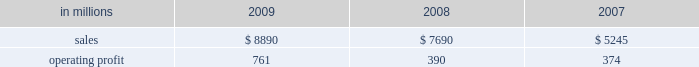Distribution xpedx , our north american merchant distribution business , distributes products and services to a number of customer markets including : commercial printers with printing papers and graphic pre-press , printing presses and post-press equipment ; building services and away-from-home markets with facility supplies ; manufacturers with packaging supplies and equipment ; and to a growing number of customers , we exclusively provide distribution capabilities including warehousing and delivery services .
Xpedx is the leading wholesale distribution marketer in these customer and product segments in north america , operating 122 warehouse locations and 130 retail stores in the united states , mexico and cana- forest products international paper owns and manages approx- imately 200000 acres of forestlands and develop- ment properties in the united states , mostly in the south .
Our remaining forestlands are managed as a portfolio to optimize the economic value to our shareholders .
Most of our portfolio represents prop- erties that are likely to be sold to investors and other buyers for various purposes .
Specialty businesses and other chemicals : this business was sold in the first quarter of 2007 .
Ilim holding s.a .
In october 2007 , international paper and ilim holding s.a .
( ilim ) completed a 50:50 joint venture to operate a pulp and paper business located in russia .
Ilim 2019s facilities include three paper mills located in bratsk , ust-ilimsk , and koryazhma , russia , with combined total pulp and paper capacity of over 2.5 million tons .
Ilim has exclusive harvesting rights on timberland and forest areas exceeding 12.8 million acres ( 5.2 million hectares ) .
Products and brand designations appearing in italics are trademarks of international paper or a related company .
Industry segment results industrial packaging demand for industrial packaging products is closely correlated with non-durable industrial goods pro- duction , as well as with demand for processed foods , poultry , meat and agricultural products .
In addition to prices and volumes , major factors affecting the profitability of industrial packaging are raw material and energy costs , freight costs , manufacturing effi- ciency and product mix .
Industrial packaging results for 2009 and 2008 include the cbpr business acquired in the 2008 third quarter .
Net sales for 2009 increased 16% ( 16 % ) to $ 8.9 billion compared with $ 7.7 billion in 2008 , and 69% ( 69 % ) compared with $ 5.2 billion in 2007 .
Operating profits were 95% ( 95 % ) higher in 2009 than in 2008 and more than double 2007 levels .
Benefits from higher total year-over-year shipments , including the impact of the cbpr business , ( $ 11 million ) , favorable operating costs ( $ 294 million ) , and lower raw material and freight costs ( $ 295 million ) were parti- ally offset by the effects of lower price realizations ( $ 243 million ) , higher corporate overhead allocations ( $ 85 million ) , incremental integration costs asso- ciated with the acquisition of the cbpr business ( $ 3 million ) and higher other costs ( $ 7 million ) .
Additionally , operating profits in 2009 included a gain of $ 849 million relating to alternative fuel mix- ture credits , u.s .
Plant closure costs of $ 653 million , and costs associated with the shutdown of the eti- enne mill in france of $ 87 million .
Industrial packaging in millions 2009 2008 2007 .
North american industrial packaging results include the net sales and operating profits of the cbpr business from the august 4 , 2008 acquis- ition date .
Net sales were $ 7.6 billion in 2009 com- pared with $ 6.2 billion in 2008 and $ 3.9 billion in 2007 .
Operating profits in 2009 were $ 791 million ( $ 682 million excluding alternative fuel mixture cred- its , mill closure costs and costs associated with the cbpr integration ) compared with $ 322 million ( $ 414 million excluding charges related to the write-up of cbpr inventory to fair value , cbpr integration costs and other facility closure costs ) in 2008 and $ 305 million in 2007 .
Excluding the effect of the cbpr acquisition , con- tainerboard and box shipments were lower in 2009 compared with 2008 reflecting weaker customer demand .
Average sales price realizations were sig- nificantly lower for both containerboard and boxes due to weaker world-wide economic conditions .
However , average sales margins for boxes .
What is the value of operating expenses and other costs concerning the activities , in 2007? 
Rationale: it is the value of sales ( operating income ) subtracted by the value of operating profit .
Computations: (5245 - 374)
Answer: 4871.0. 